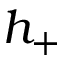Convert formula to latex. <formula><loc_0><loc_0><loc_500><loc_500>h _ { + }</formula> 